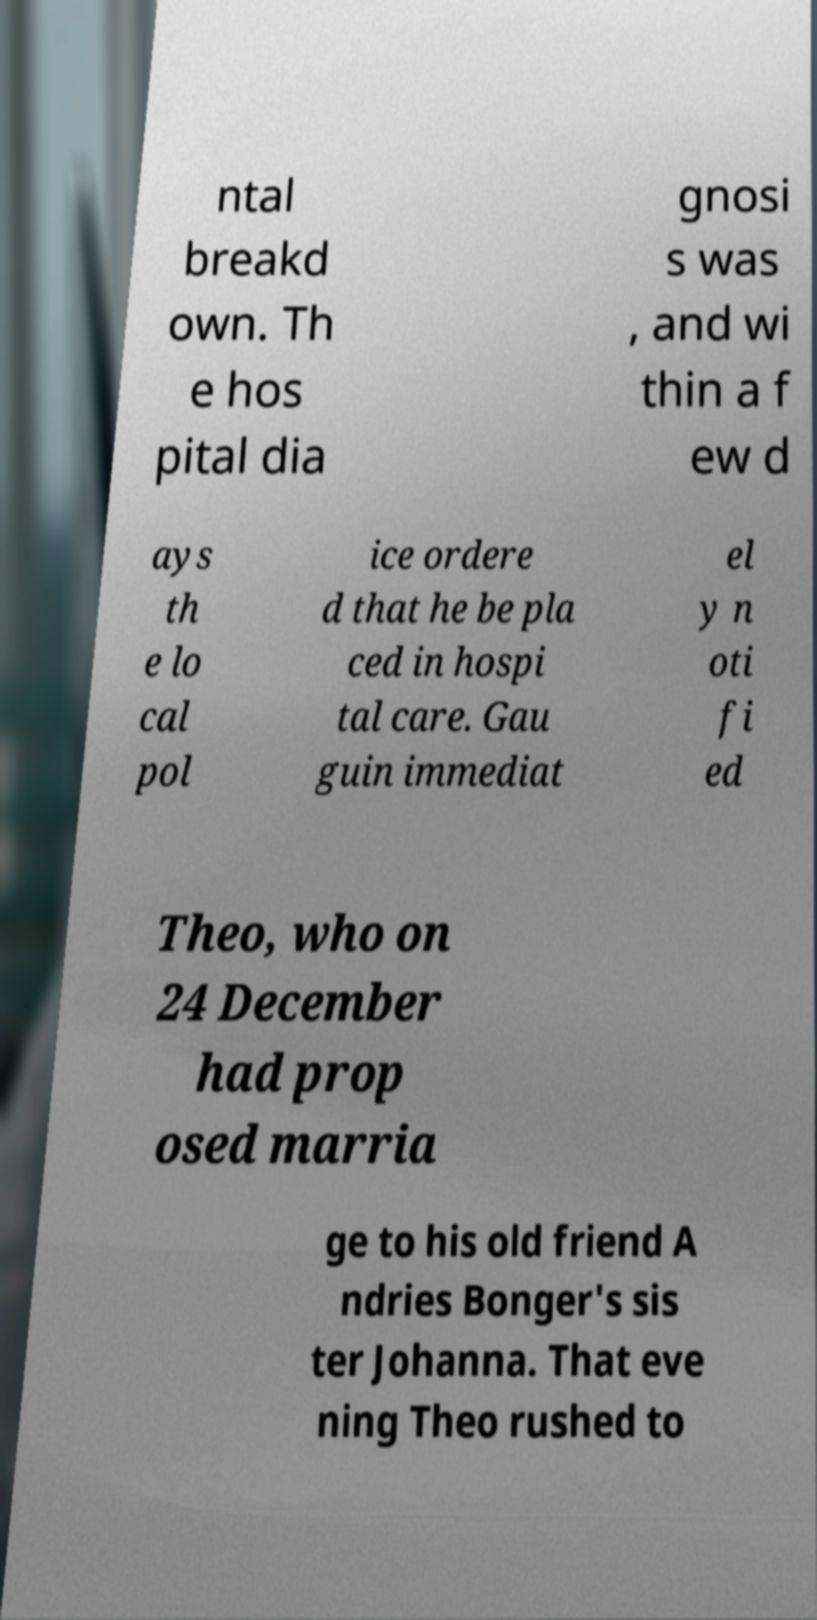Can you read and provide the text displayed in the image?This photo seems to have some interesting text. Can you extract and type it out for me? ntal breakd own. Th e hos pital dia gnosi s was , and wi thin a f ew d ays th e lo cal pol ice ordere d that he be pla ced in hospi tal care. Gau guin immediat el y n oti fi ed Theo, who on 24 December had prop osed marria ge to his old friend A ndries Bonger's sis ter Johanna. That eve ning Theo rushed to 